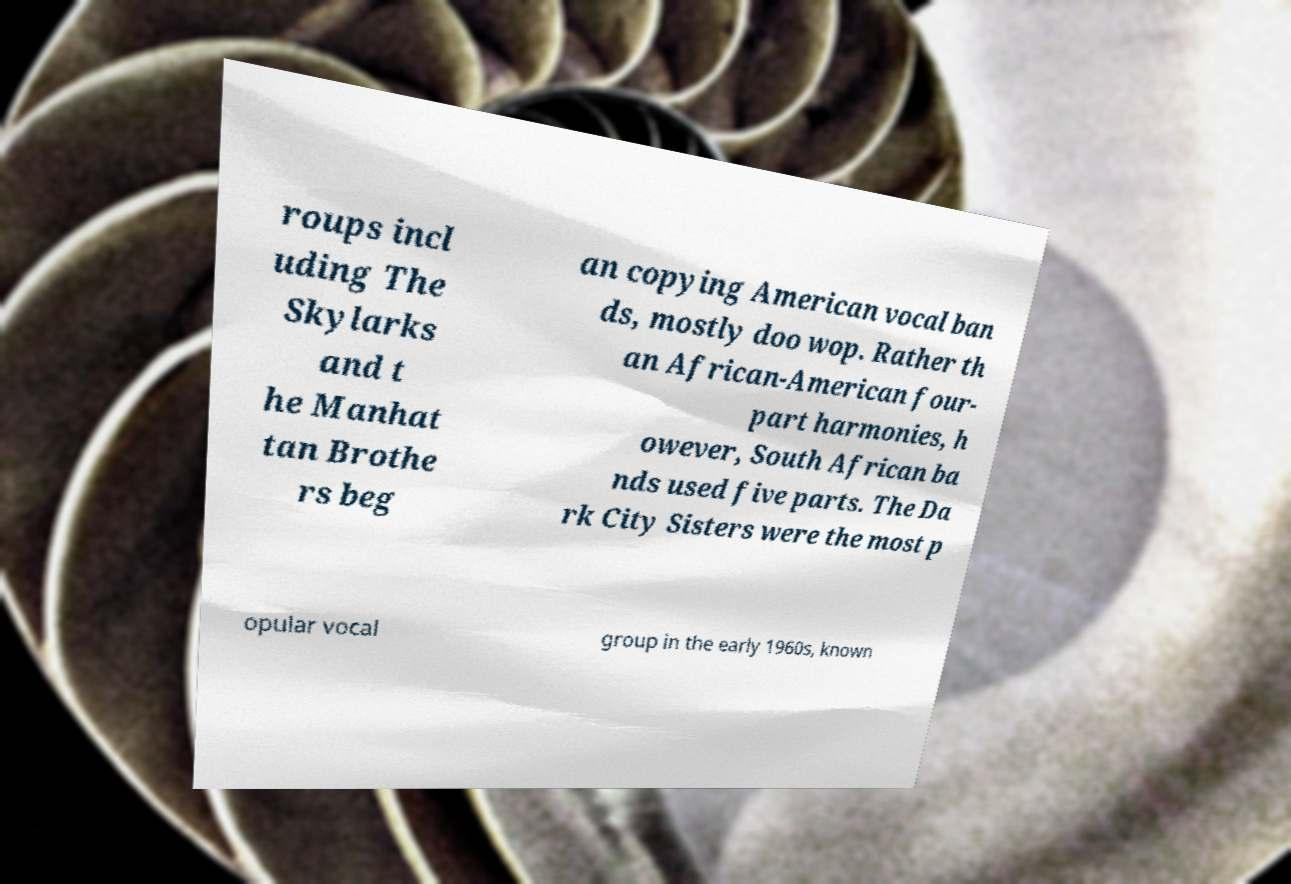For documentation purposes, I need the text within this image transcribed. Could you provide that? roups incl uding The Skylarks and t he Manhat tan Brothe rs beg an copying American vocal ban ds, mostly doo wop. Rather th an African-American four- part harmonies, h owever, South African ba nds used five parts. The Da rk City Sisters were the most p opular vocal group in the early 1960s, known 